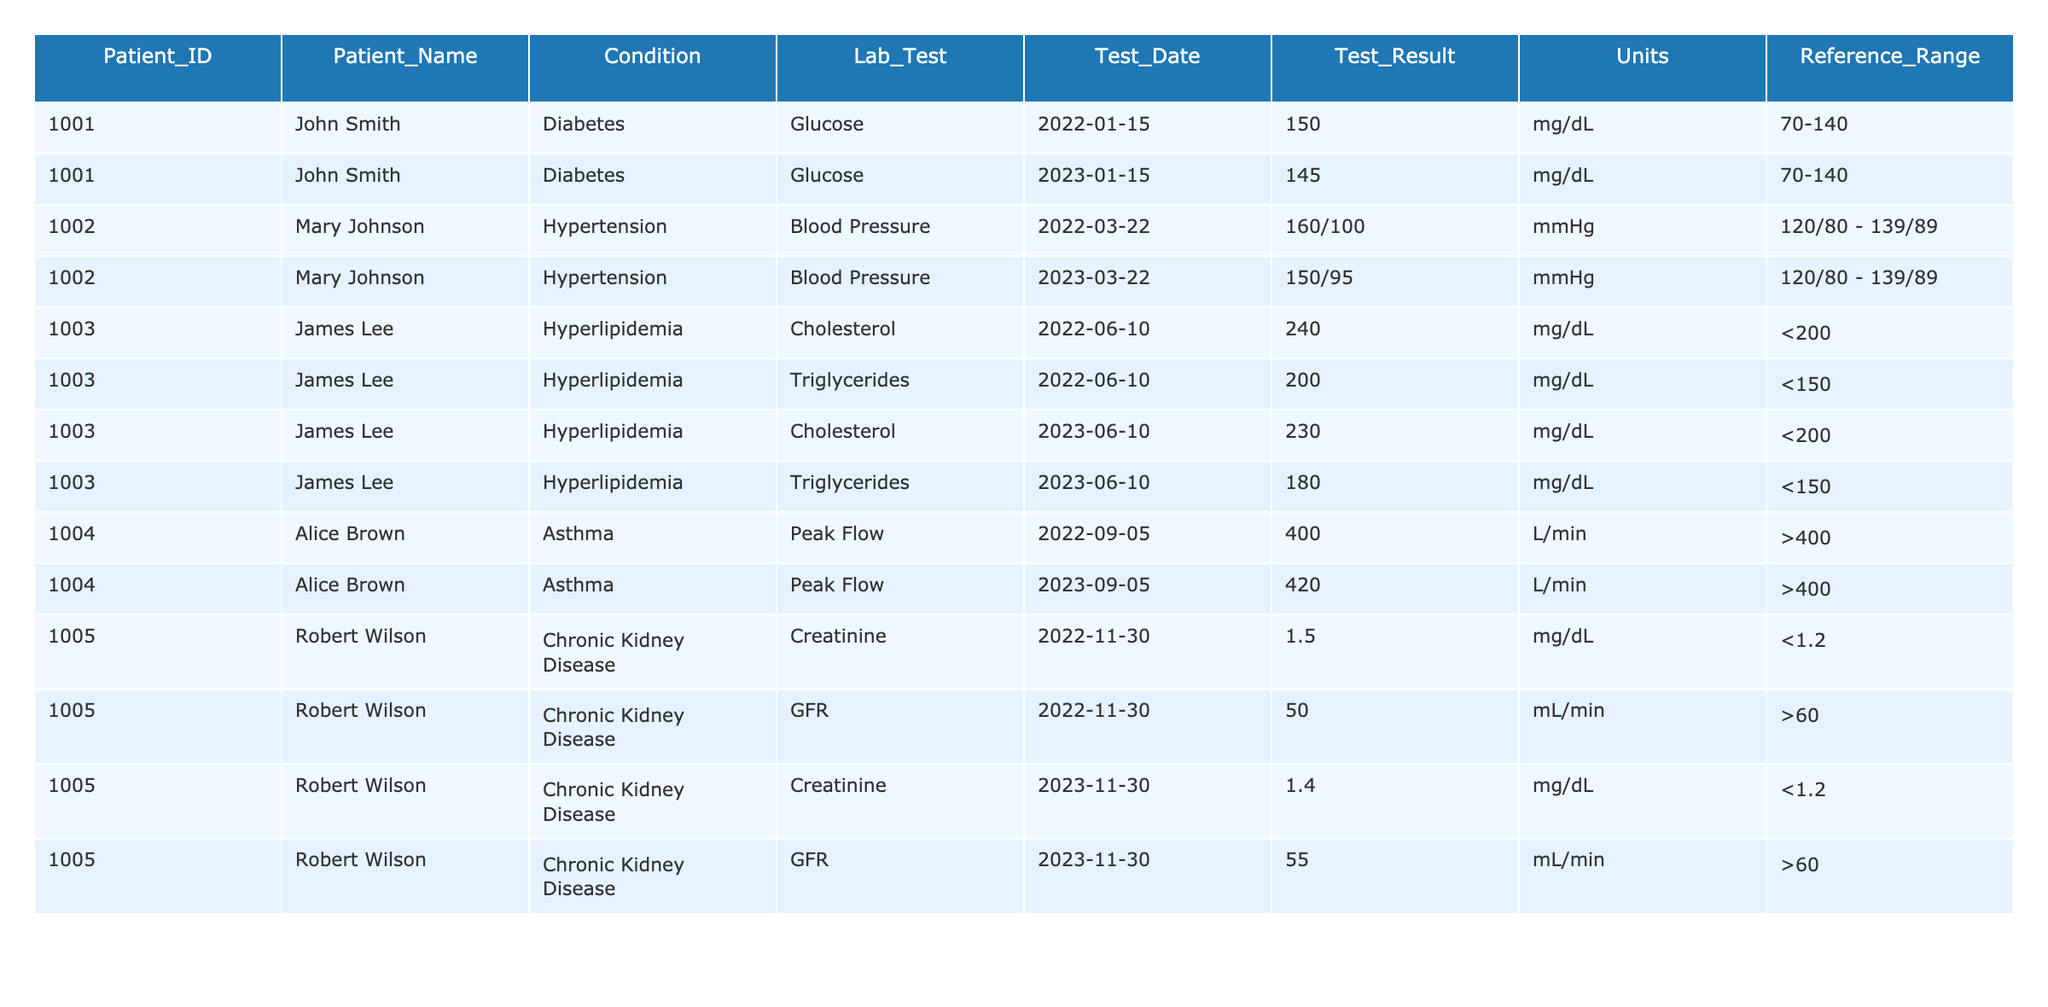What was John Smith's glucose level in 2023? John Smith had a glucose level of 145 mg/dL in 2023 as recorded on January 15, 2023.
Answer: 145 mg/dL Was Robert Wilson's GFR value above the reference range in 2022? Robert Wilson's GFR value was 50 mL/min in 2022, which is below the reference range of greater than 60 mL/min.
Answer: No How did Mary Johnson's blood pressure change from 2022 to 2023? In 2022, Mary Johnson's blood pressure was 160/100 mmHg, which decreased to 150/95 mmHg in 2023. This indicates a decrease in both systolic and diastolic values.
Answer: Decreased What is the difference in cholesterol levels for James Lee from 2022 to 2023? James Lee's cholesterol level decreased from 240 mg/dL in 2022 to 230 mg/dL in 2023. The difference is 10 mg/dL (240 - 230 = 10).
Answer: 10 mg/dL Did Alice Brown's peak flow improve from 2022 to 2023? Alice Brown's peak flow improved from 400 L/min in 2022 to 420 L/min in 2023, indicating an increase in her lung function.
Answer: Yes What is the average creatinine level for Robert Wilson in the recorded years? Robert Wilson's creatinine levels were 1.5 mg/dL in 2022 and 1.4 mg/dL in 2023. The average is calculated as (1.5 + 1.4) / 2 = 1.45 mg/dL.
Answer: 1.45 mg/dL How many lab tests were conducted for James Lee, and what were the conditions? James Lee underwent two lab tests for Hyperlipidemia: cholesterol and triglycerides, both in 2022 and 2023. This amounts to four tests in total.
Answer: Four tests Has there been any improvement in triglyceride levels for James Lee over time? James Lee's triglyceride levels improved from 200 mg/dL in 2022 to 180 mg/dL in 2023, indicating a positive change.
Answer: Yes 